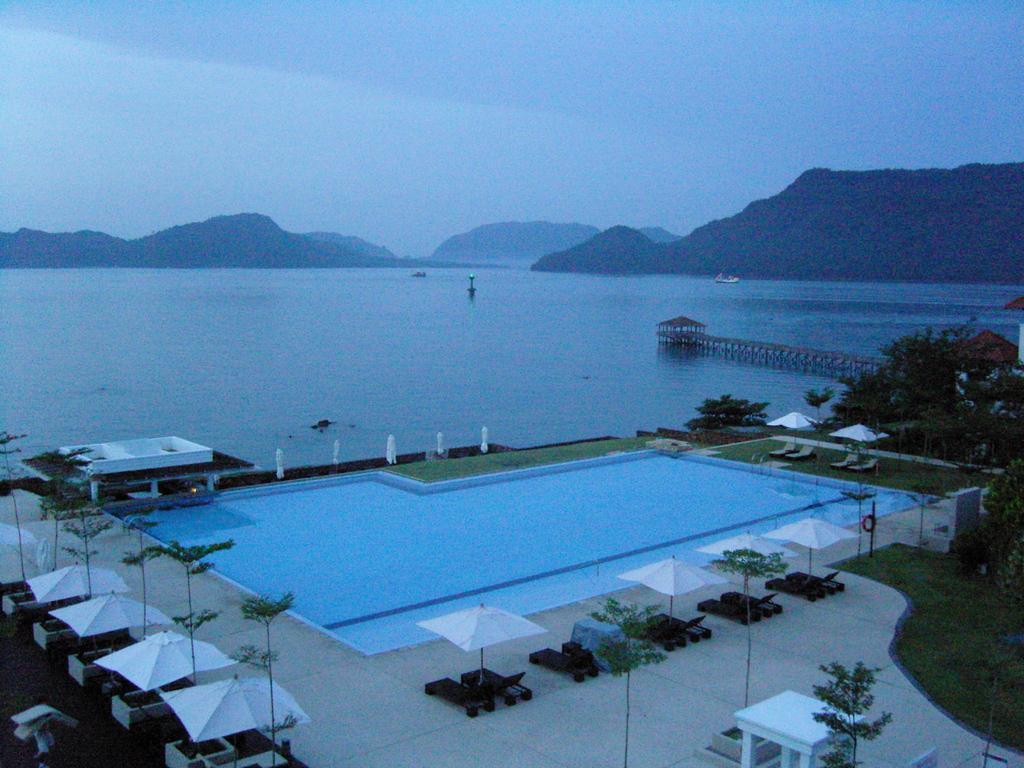Please provide a concise description of this image. In the center of the image there is a swimming pool. There is a building. There are tents. There are trees. In the background of the image there are mountains and water. At the top of the image there is sky. 